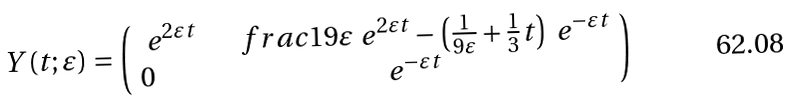Convert formula to latex. <formula><loc_0><loc_0><loc_500><loc_500>Y ( t ; \varepsilon ) = \left ( \begin{array} { l c } \ e ^ { 2 \varepsilon t } & \quad f r a c { 1 } { 9 \varepsilon } \ e ^ { 2 \varepsilon t } - \left ( \frac { 1 } { 9 \varepsilon } + \frac { 1 } { 3 } t \right ) \ e ^ { - \varepsilon t } \\ 0 & \ e ^ { - \varepsilon t } \end{array} \right )</formula> 